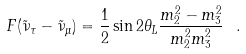Convert formula to latex. <formula><loc_0><loc_0><loc_500><loc_500>F ( \tilde { \nu } _ { \tau } - \tilde { \nu } _ { \mu } ) = \frac { 1 } { 2 } \sin 2 \theta _ { L } \frac { m _ { 2 } ^ { 2 } - m _ { 3 } ^ { 2 } } { m _ { 2 } ^ { 2 } m _ { 3 } ^ { 2 } } \ .</formula> 